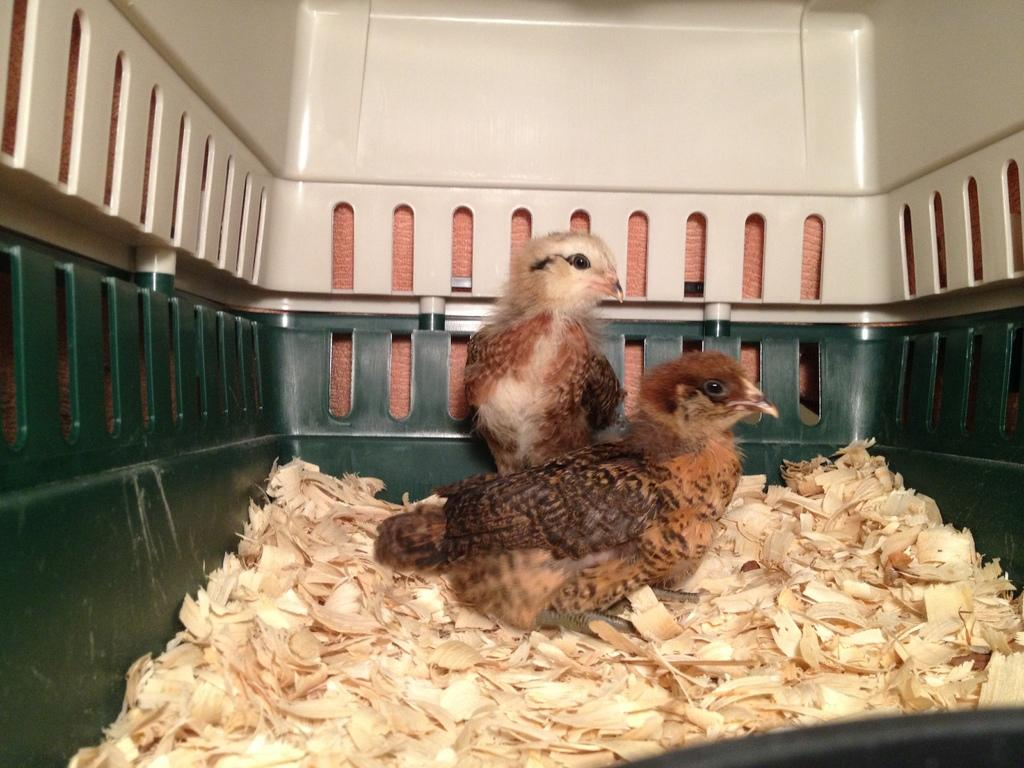What animals are present in the image? There are two birds in the image. Where are the birds located? The birds are in a basket. What else is present in the basket besides the birds? There is trash in the basket. What type of curtain can be seen hanging from the birds' beaks in the image? There is no curtain present in the image, and the birds' beaks are not holding any curtains. How many potatoes are visible in the image? There are no potatoes present in the image. Are there any clams visible in the image? There are no clams present in the image. 